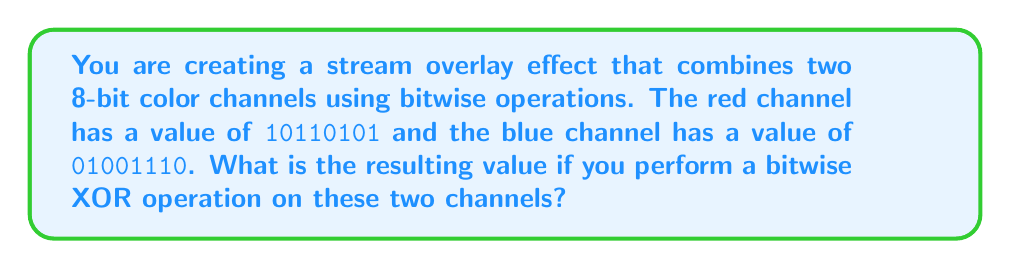Teach me how to tackle this problem. To solve this problem, we need to perform a bitwise XOR operation on the two given 8-bit values. The XOR operation returns 1 if the bits are different and 0 if they are the same.

Let's break it down step by step:

1. Align the binary numbers:
   $$
   \begin{array}{r}
   \text{Red channel:}  & 10110101 \\
   \text{Blue channel:} & 01001110
   \end{array}
   $$

2. Perform XOR operation bit by bit:
   $$
   \begin{array}{r}
   \text{Red channel:}  & 1 & 0 & 1 & 1 & 0 & 1 & 0 & 1 \\
   \text{Blue channel:} & 0 & 1 & 0 & 0 & 1 & 1 & 1 & 0 \\
   \hline
   \text{XOR result:}   & 1 & 1 & 1 & 1 & 1 & 0 & 1 & 1
   \end{array}
   $$

3. The resulting binary value after XOR operation is 11111011.

This binary value can be useful for creating various overlay effects in streaming software, as it combines information from both color channels in a way that highlights their differences.
Answer: 11111011 